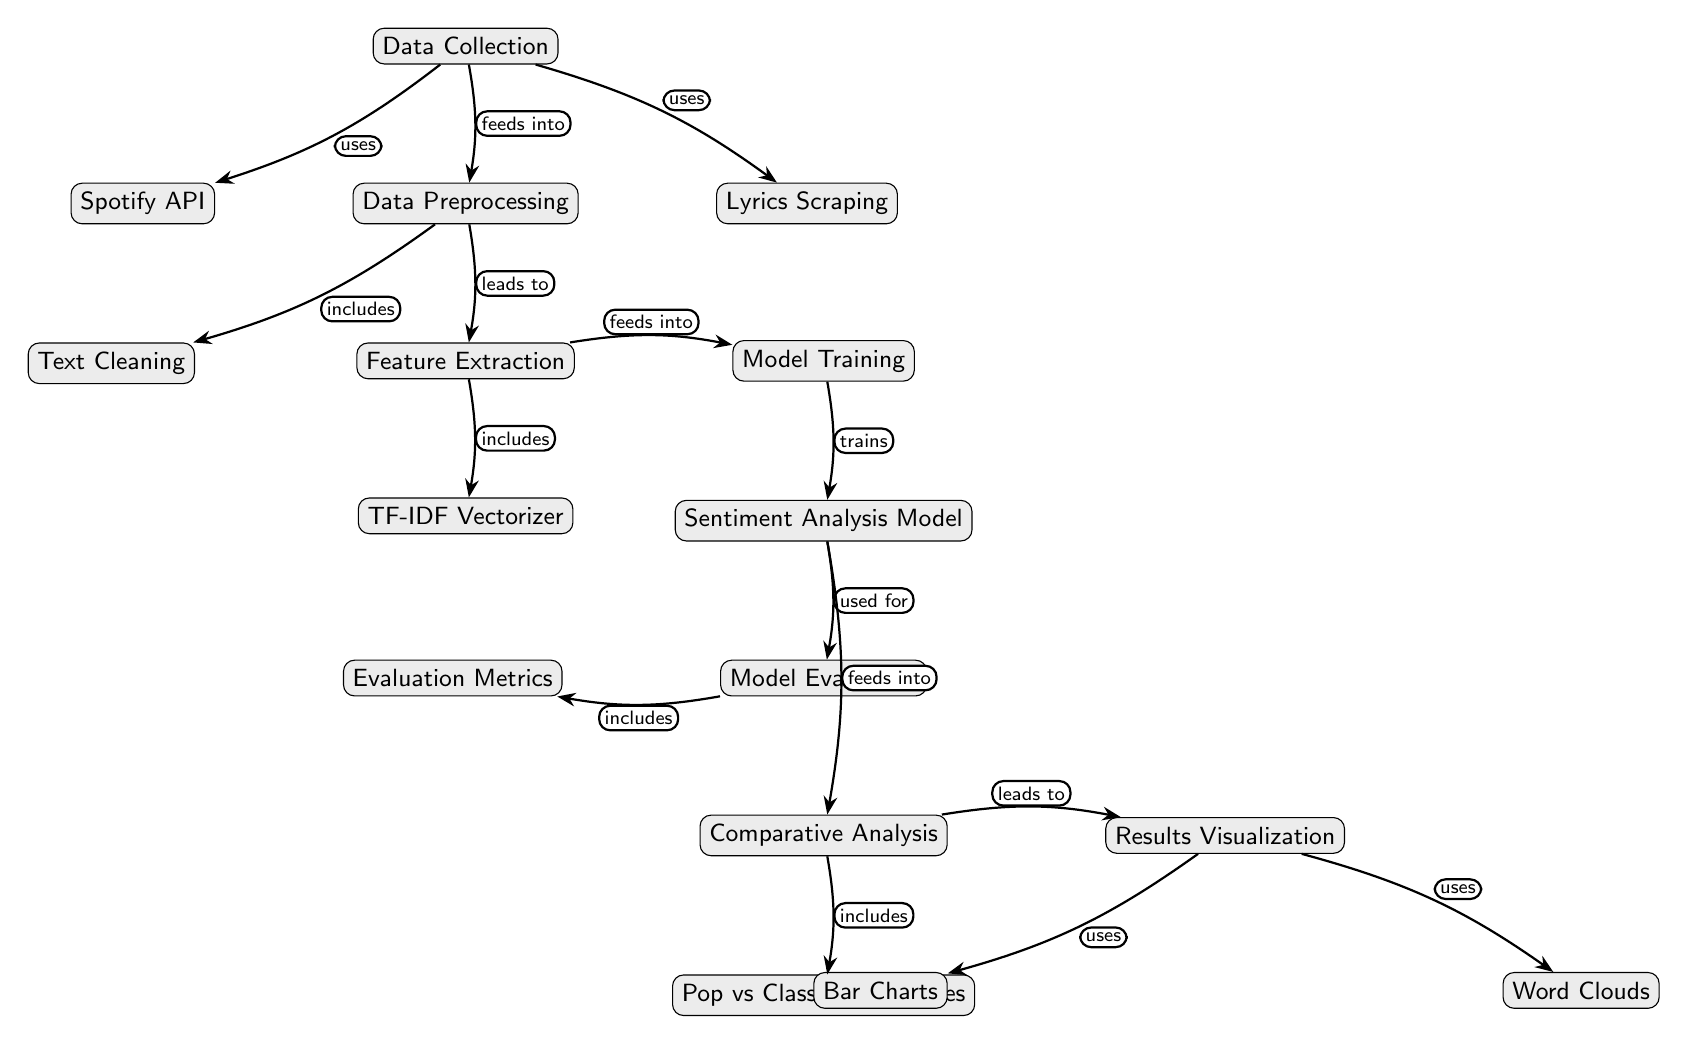What are the two primary methods used for data collection? The diagram shows two nodes under the "Data Collection" process: "Spotify API" and "Lyrics Scraping," indicating these are the primary sources for gathering data.
Answer: Spotify API, Lyrics Scraping How many nodes are there in total? By counting all the distinct nodes in the diagram, we find a total of 13 nodes such as Data Collection, Preprocessing, Feature Extraction, etc.
Answer: 13 What does "Data Preprocessing" include? The diagram specifies that "Data Preprocessing" includes a sub-node labeled "Text Cleaning," which is directly connected to it.
Answer: Text Cleaning What is the output of "Feature Extraction"? The flow from "Feature Extraction" leads to model training, so its output can be considered as feeding into "Model Training."
Answer: Model Training Which two visualization techniques are used in the "Results Visualization" step? The diagram shows that "Results Visualization" uses two outputs: "Bar Charts" and "Word Clouds," indicating these are the techniques employed for visual representation.
Answer: Bar Charts, Word Clouds What is the purpose of the "Evaluation Metrics" node? The diagram connects "Evaluation Metrics" to the "Model Evaluation" node, indicating that it is used to assess the performance and effectiveness of the sentiment analysis model.
Answer: To assess performance What is involved in "Model Training"? According to the diagram, "Model Training" involves using the "Sentiment Analysis Model," which is directly connected and indicates that the training process is specifically for developing this model.
Answer: Sentiment Analysis Model What does "Comparative Analysis" include? The diagram indicates that "Comparative Analysis" includes a comparison between "Pop vs Classical Influences," showing what aspects will be compared in this phase.
Answer: Pop vs Classical Influences How does "Data Collection" connect to "Preprocessing"? The flow shows that the "Data Collection" feeds into the "Data Preprocessing" node, demonstrating a direct link where collected data is processed next.
Answer: Feeds into 